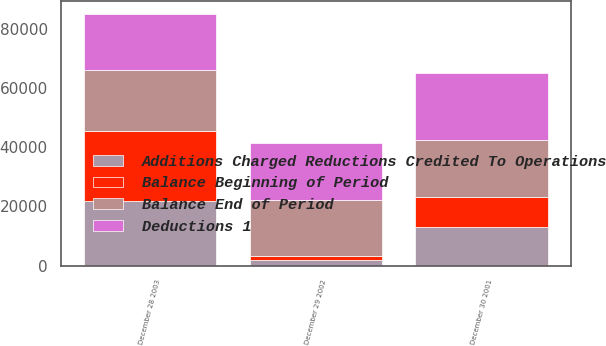Convert chart. <chart><loc_0><loc_0><loc_500><loc_500><stacked_bar_chart><ecel><fcel>December 30 2001<fcel>December 29 2002<fcel>December 28 2003<nl><fcel>Deductions 1<fcel>22712<fcel>19270<fcel>18906<nl><fcel>Balance Beginning of Period<fcel>9791<fcel>1456<fcel>23541<nl><fcel>Additions Charged Reductions Credited To Operations<fcel>13233<fcel>1820<fcel>21789<nl><fcel>Balance End of Period<fcel>19270<fcel>18906<fcel>20658<nl></chart> 